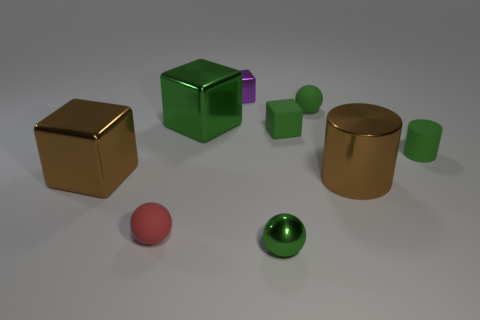What material is the small cube that is the same color as the tiny cylinder?
Your response must be concise. Rubber. Are there fewer brown things that are to the right of the green shiny ball than big green shiny things that are to the right of the purple thing?
Provide a short and direct response. No. There is a large brown metal block; what number of tiny green spheres are in front of it?
Keep it short and to the point. 1. There is a small green rubber object behind the tiny green cube; is its shape the same as the matte thing in front of the big brown block?
Your answer should be very brief. Yes. How many other things are there of the same color as the large cylinder?
Ensure brevity in your answer.  1. What is the material of the tiny green thing in front of the object that is on the left side of the small matte object that is in front of the small cylinder?
Keep it short and to the point. Metal. What material is the red ball in front of the big cube that is left of the red matte sphere?
Your answer should be compact. Rubber. Are there fewer matte spheres that are on the right side of the tiny matte cylinder than small green matte cylinders?
Keep it short and to the point. Yes. What shape is the tiny red matte object that is on the left side of the green matte sphere?
Make the answer very short. Sphere. There is a green shiny block; is its size the same as the matte ball behind the green metallic block?
Your answer should be compact. No. 